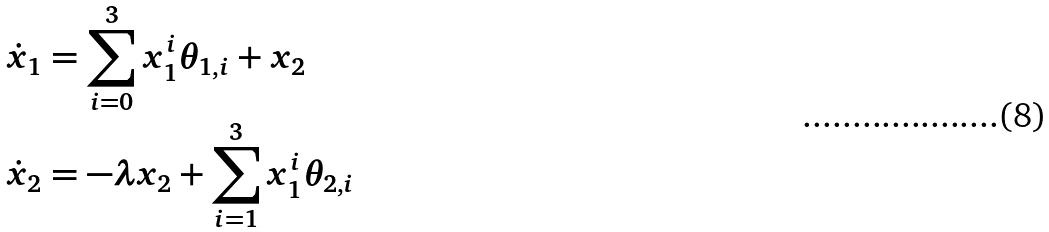Convert formula to latex. <formula><loc_0><loc_0><loc_500><loc_500>\dot { x } _ { 1 } & = \sum _ { i = 0 } ^ { 3 } x _ { 1 } ^ { i } \theta _ { 1 , i } + x _ { 2 } \\ \dot { x } _ { 2 } & = - \lambda x _ { 2 } + \sum _ { i = 1 } ^ { 3 } x _ { 1 } ^ { i } \theta _ { 2 , i }</formula> 